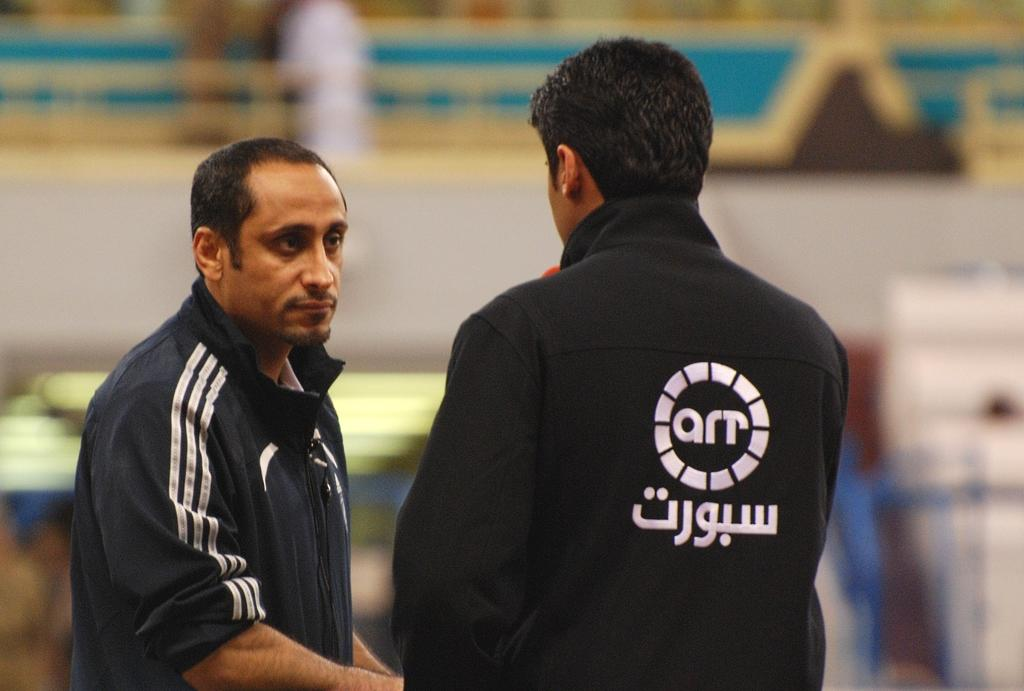<image>
Relay a brief, clear account of the picture shown. Man talking to another man while wearing a sweater that says "AR". 